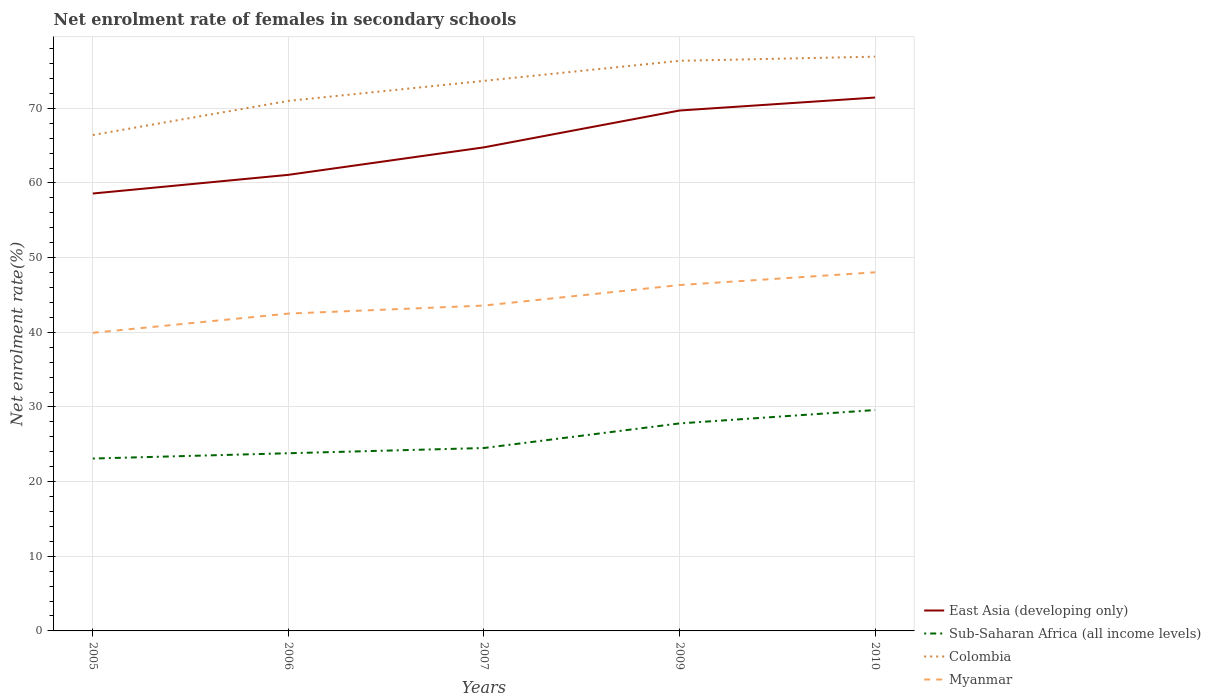How many different coloured lines are there?
Your answer should be very brief. 4. Does the line corresponding to East Asia (developing only) intersect with the line corresponding to Sub-Saharan Africa (all income levels)?
Your response must be concise. No. Is the number of lines equal to the number of legend labels?
Provide a succinct answer. Yes. Across all years, what is the maximum net enrolment rate of females in secondary schools in East Asia (developing only)?
Your answer should be compact. 58.59. What is the total net enrolment rate of females in secondary schools in Sub-Saharan Africa (all income levels) in the graph?
Your answer should be very brief. -0.7. What is the difference between the highest and the second highest net enrolment rate of females in secondary schools in Sub-Saharan Africa (all income levels)?
Offer a very short reply. 6.5. How many years are there in the graph?
Provide a short and direct response. 5. What is the difference between two consecutive major ticks on the Y-axis?
Make the answer very short. 10. Are the values on the major ticks of Y-axis written in scientific E-notation?
Provide a short and direct response. No. Does the graph contain any zero values?
Keep it short and to the point. No. Where does the legend appear in the graph?
Offer a very short reply. Bottom right. How many legend labels are there?
Your response must be concise. 4. What is the title of the graph?
Ensure brevity in your answer.  Net enrolment rate of females in secondary schools. Does "Sub-Saharan Africa (developing only)" appear as one of the legend labels in the graph?
Keep it short and to the point. No. What is the label or title of the Y-axis?
Keep it short and to the point. Net enrolment rate(%). What is the Net enrolment rate(%) in East Asia (developing only) in 2005?
Offer a very short reply. 58.59. What is the Net enrolment rate(%) in Sub-Saharan Africa (all income levels) in 2005?
Your answer should be compact. 23.09. What is the Net enrolment rate(%) of Colombia in 2005?
Provide a succinct answer. 66.43. What is the Net enrolment rate(%) in Myanmar in 2005?
Provide a succinct answer. 39.93. What is the Net enrolment rate(%) in East Asia (developing only) in 2006?
Provide a short and direct response. 61.09. What is the Net enrolment rate(%) of Sub-Saharan Africa (all income levels) in 2006?
Ensure brevity in your answer.  23.8. What is the Net enrolment rate(%) of Colombia in 2006?
Provide a succinct answer. 71. What is the Net enrolment rate(%) in Myanmar in 2006?
Keep it short and to the point. 42.51. What is the Net enrolment rate(%) in East Asia (developing only) in 2007?
Provide a succinct answer. 64.77. What is the Net enrolment rate(%) in Sub-Saharan Africa (all income levels) in 2007?
Provide a succinct answer. 24.5. What is the Net enrolment rate(%) in Colombia in 2007?
Offer a terse response. 73.68. What is the Net enrolment rate(%) in Myanmar in 2007?
Your answer should be compact. 43.58. What is the Net enrolment rate(%) of East Asia (developing only) in 2009?
Your response must be concise. 69.71. What is the Net enrolment rate(%) in Sub-Saharan Africa (all income levels) in 2009?
Your response must be concise. 27.79. What is the Net enrolment rate(%) of Colombia in 2009?
Keep it short and to the point. 76.37. What is the Net enrolment rate(%) of Myanmar in 2009?
Provide a short and direct response. 46.33. What is the Net enrolment rate(%) in East Asia (developing only) in 2010?
Provide a short and direct response. 71.45. What is the Net enrolment rate(%) of Sub-Saharan Africa (all income levels) in 2010?
Keep it short and to the point. 29.59. What is the Net enrolment rate(%) in Colombia in 2010?
Make the answer very short. 76.92. What is the Net enrolment rate(%) of Myanmar in 2010?
Provide a short and direct response. 48.03. Across all years, what is the maximum Net enrolment rate(%) in East Asia (developing only)?
Your answer should be compact. 71.45. Across all years, what is the maximum Net enrolment rate(%) of Sub-Saharan Africa (all income levels)?
Provide a short and direct response. 29.59. Across all years, what is the maximum Net enrolment rate(%) of Colombia?
Make the answer very short. 76.92. Across all years, what is the maximum Net enrolment rate(%) in Myanmar?
Keep it short and to the point. 48.03. Across all years, what is the minimum Net enrolment rate(%) of East Asia (developing only)?
Give a very brief answer. 58.59. Across all years, what is the minimum Net enrolment rate(%) in Sub-Saharan Africa (all income levels)?
Offer a very short reply. 23.09. Across all years, what is the minimum Net enrolment rate(%) of Colombia?
Make the answer very short. 66.43. Across all years, what is the minimum Net enrolment rate(%) in Myanmar?
Give a very brief answer. 39.93. What is the total Net enrolment rate(%) of East Asia (developing only) in the graph?
Your response must be concise. 325.61. What is the total Net enrolment rate(%) in Sub-Saharan Africa (all income levels) in the graph?
Offer a very short reply. 128.78. What is the total Net enrolment rate(%) of Colombia in the graph?
Offer a very short reply. 364.4. What is the total Net enrolment rate(%) in Myanmar in the graph?
Offer a terse response. 220.39. What is the difference between the Net enrolment rate(%) of East Asia (developing only) in 2005 and that in 2006?
Ensure brevity in your answer.  -2.5. What is the difference between the Net enrolment rate(%) in Sub-Saharan Africa (all income levels) in 2005 and that in 2006?
Your response must be concise. -0.71. What is the difference between the Net enrolment rate(%) of Colombia in 2005 and that in 2006?
Make the answer very short. -4.57. What is the difference between the Net enrolment rate(%) in Myanmar in 2005 and that in 2006?
Provide a short and direct response. -2.57. What is the difference between the Net enrolment rate(%) of East Asia (developing only) in 2005 and that in 2007?
Your answer should be very brief. -6.18. What is the difference between the Net enrolment rate(%) in Sub-Saharan Africa (all income levels) in 2005 and that in 2007?
Your answer should be very brief. -1.41. What is the difference between the Net enrolment rate(%) in Colombia in 2005 and that in 2007?
Offer a very short reply. -7.25. What is the difference between the Net enrolment rate(%) of Myanmar in 2005 and that in 2007?
Your answer should be very brief. -3.65. What is the difference between the Net enrolment rate(%) in East Asia (developing only) in 2005 and that in 2009?
Offer a very short reply. -11.12. What is the difference between the Net enrolment rate(%) in Sub-Saharan Africa (all income levels) in 2005 and that in 2009?
Make the answer very short. -4.7. What is the difference between the Net enrolment rate(%) in Colombia in 2005 and that in 2009?
Ensure brevity in your answer.  -9.94. What is the difference between the Net enrolment rate(%) of Myanmar in 2005 and that in 2009?
Your answer should be very brief. -6.39. What is the difference between the Net enrolment rate(%) of East Asia (developing only) in 2005 and that in 2010?
Keep it short and to the point. -12.85. What is the difference between the Net enrolment rate(%) of Sub-Saharan Africa (all income levels) in 2005 and that in 2010?
Provide a succinct answer. -6.5. What is the difference between the Net enrolment rate(%) in Colombia in 2005 and that in 2010?
Ensure brevity in your answer.  -10.49. What is the difference between the Net enrolment rate(%) in Myanmar in 2005 and that in 2010?
Ensure brevity in your answer.  -8.1. What is the difference between the Net enrolment rate(%) in East Asia (developing only) in 2006 and that in 2007?
Provide a short and direct response. -3.68. What is the difference between the Net enrolment rate(%) of Sub-Saharan Africa (all income levels) in 2006 and that in 2007?
Make the answer very short. -0.7. What is the difference between the Net enrolment rate(%) in Colombia in 2006 and that in 2007?
Ensure brevity in your answer.  -2.68. What is the difference between the Net enrolment rate(%) in Myanmar in 2006 and that in 2007?
Keep it short and to the point. -1.08. What is the difference between the Net enrolment rate(%) of East Asia (developing only) in 2006 and that in 2009?
Provide a short and direct response. -8.62. What is the difference between the Net enrolment rate(%) in Sub-Saharan Africa (all income levels) in 2006 and that in 2009?
Your answer should be compact. -3.99. What is the difference between the Net enrolment rate(%) in Colombia in 2006 and that in 2009?
Your answer should be very brief. -5.37. What is the difference between the Net enrolment rate(%) in Myanmar in 2006 and that in 2009?
Your answer should be very brief. -3.82. What is the difference between the Net enrolment rate(%) in East Asia (developing only) in 2006 and that in 2010?
Keep it short and to the point. -10.35. What is the difference between the Net enrolment rate(%) in Sub-Saharan Africa (all income levels) in 2006 and that in 2010?
Make the answer very short. -5.79. What is the difference between the Net enrolment rate(%) in Colombia in 2006 and that in 2010?
Give a very brief answer. -5.92. What is the difference between the Net enrolment rate(%) of Myanmar in 2006 and that in 2010?
Provide a succinct answer. -5.53. What is the difference between the Net enrolment rate(%) in East Asia (developing only) in 2007 and that in 2009?
Make the answer very short. -4.93. What is the difference between the Net enrolment rate(%) of Sub-Saharan Africa (all income levels) in 2007 and that in 2009?
Make the answer very short. -3.29. What is the difference between the Net enrolment rate(%) in Colombia in 2007 and that in 2009?
Provide a succinct answer. -2.68. What is the difference between the Net enrolment rate(%) in Myanmar in 2007 and that in 2009?
Keep it short and to the point. -2.75. What is the difference between the Net enrolment rate(%) in East Asia (developing only) in 2007 and that in 2010?
Give a very brief answer. -6.67. What is the difference between the Net enrolment rate(%) in Sub-Saharan Africa (all income levels) in 2007 and that in 2010?
Give a very brief answer. -5.09. What is the difference between the Net enrolment rate(%) of Colombia in 2007 and that in 2010?
Provide a short and direct response. -3.24. What is the difference between the Net enrolment rate(%) in Myanmar in 2007 and that in 2010?
Your answer should be compact. -4.45. What is the difference between the Net enrolment rate(%) in East Asia (developing only) in 2009 and that in 2010?
Your answer should be compact. -1.74. What is the difference between the Net enrolment rate(%) in Sub-Saharan Africa (all income levels) in 2009 and that in 2010?
Your response must be concise. -1.79. What is the difference between the Net enrolment rate(%) in Colombia in 2009 and that in 2010?
Ensure brevity in your answer.  -0.55. What is the difference between the Net enrolment rate(%) in Myanmar in 2009 and that in 2010?
Your answer should be compact. -1.7. What is the difference between the Net enrolment rate(%) in East Asia (developing only) in 2005 and the Net enrolment rate(%) in Sub-Saharan Africa (all income levels) in 2006?
Make the answer very short. 34.79. What is the difference between the Net enrolment rate(%) in East Asia (developing only) in 2005 and the Net enrolment rate(%) in Colombia in 2006?
Provide a succinct answer. -12.41. What is the difference between the Net enrolment rate(%) of East Asia (developing only) in 2005 and the Net enrolment rate(%) of Myanmar in 2006?
Your response must be concise. 16.09. What is the difference between the Net enrolment rate(%) in Sub-Saharan Africa (all income levels) in 2005 and the Net enrolment rate(%) in Colombia in 2006?
Your answer should be very brief. -47.91. What is the difference between the Net enrolment rate(%) in Sub-Saharan Africa (all income levels) in 2005 and the Net enrolment rate(%) in Myanmar in 2006?
Give a very brief answer. -19.41. What is the difference between the Net enrolment rate(%) in Colombia in 2005 and the Net enrolment rate(%) in Myanmar in 2006?
Your answer should be compact. 23.93. What is the difference between the Net enrolment rate(%) in East Asia (developing only) in 2005 and the Net enrolment rate(%) in Sub-Saharan Africa (all income levels) in 2007?
Offer a very short reply. 34.09. What is the difference between the Net enrolment rate(%) of East Asia (developing only) in 2005 and the Net enrolment rate(%) of Colombia in 2007?
Offer a terse response. -15.09. What is the difference between the Net enrolment rate(%) of East Asia (developing only) in 2005 and the Net enrolment rate(%) of Myanmar in 2007?
Offer a very short reply. 15.01. What is the difference between the Net enrolment rate(%) of Sub-Saharan Africa (all income levels) in 2005 and the Net enrolment rate(%) of Colombia in 2007?
Provide a short and direct response. -50.59. What is the difference between the Net enrolment rate(%) of Sub-Saharan Africa (all income levels) in 2005 and the Net enrolment rate(%) of Myanmar in 2007?
Your answer should be compact. -20.49. What is the difference between the Net enrolment rate(%) in Colombia in 2005 and the Net enrolment rate(%) in Myanmar in 2007?
Give a very brief answer. 22.85. What is the difference between the Net enrolment rate(%) of East Asia (developing only) in 2005 and the Net enrolment rate(%) of Sub-Saharan Africa (all income levels) in 2009?
Offer a terse response. 30.8. What is the difference between the Net enrolment rate(%) of East Asia (developing only) in 2005 and the Net enrolment rate(%) of Colombia in 2009?
Offer a very short reply. -17.78. What is the difference between the Net enrolment rate(%) of East Asia (developing only) in 2005 and the Net enrolment rate(%) of Myanmar in 2009?
Your answer should be very brief. 12.26. What is the difference between the Net enrolment rate(%) in Sub-Saharan Africa (all income levels) in 2005 and the Net enrolment rate(%) in Colombia in 2009?
Give a very brief answer. -53.28. What is the difference between the Net enrolment rate(%) of Sub-Saharan Africa (all income levels) in 2005 and the Net enrolment rate(%) of Myanmar in 2009?
Offer a very short reply. -23.24. What is the difference between the Net enrolment rate(%) in Colombia in 2005 and the Net enrolment rate(%) in Myanmar in 2009?
Provide a succinct answer. 20.1. What is the difference between the Net enrolment rate(%) in East Asia (developing only) in 2005 and the Net enrolment rate(%) in Sub-Saharan Africa (all income levels) in 2010?
Offer a terse response. 29.01. What is the difference between the Net enrolment rate(%) of East Asia (developing only) in 2005 and the Net enrolment rate(%) of Colombia in 2010?
Your answer should be very brief. -18.33. What is the difference between the Net enrolment rate(%) of East Asia (developing only) in 2005 and the Net enrolment rate(%) of Myanmar in 2010?
Keep it short and to the point. 10.56. What is the difference between the Net enrolment rate(%) in Sub-Saharan Africa (all income levels) in 2005 and the Net enrolment rate(%) in Colombia in 2010?
Provide a short and direct response. -53.83. What is the difference between the Net enrolment rate(%) in Sub-Saharan Africa (all income levels) in 2005 and the Net enrolment rate(%) in Myanmar in 2010?
Provide a short and direct response. -24.94. What is the difference between the Net enrolment rate(%) in Colombia in 2005 and the Net enrolment rate(%) in Myanmar in 2010?
Your answer should be compact. 18.4. What is the difference between the Net enrolment rate(%) in East Asia (developing only) in 2006 and the Net enrolment rate(%) in Sub-Saharan Africa (all income levels) in 2007?
Give a very brief answer. 36.59. What is the difference between the Net enrolment rate(%) of East Asia (developing only) in 2006 and the Net enrolment rate(%) of Colombia in 2007?
Make the answer very short. -12.59. What is the difference between the Net enrolment rate(%) in East Asia (developing only) in 2006 and the Net enrolment rate(%) in Myanmar in 2007?
Give a very brief answer. 17.51. What is the difference between the Net enrolment rate(%) of Sub-Saharan Africa (all income levels) in 2006 and the Net enrolment rate(%) of Colombia in 2007?
Keep it short and to the point. -49.88. What is the difference between the Net enrolment rate(%) of Sub-Saharan Africa (all income levels) in 2006 and the Net enrolment rate(%) of Myanmar in 2007?
Give a very brief answer. -19.78. What is the difference between the Net enrolment rate(%) in Colombia in 2006 and the Net enrolment rate(%) in Myanmar in 2007?
Provide a short and direct response. 27.42. What is the difference between the Net enrolment rate(%) of East Asia (developing only) in 2006 and the Net enrolment rate(%) of Sub-Saharan Africa (all income levels) in 2009?
Ensure brevity in your answer.  33.3. What is the difference between the Net enrolment rate(%) in East Asia (developing only) in 2006 and the Net enrolment rate(%) in Colombia in 2009?
Offer a terse response. -15.28. What is the difference between the Net enrolment rate(%) in East Asia (developing only) in 2006 and the Net enrolment rate(%) in Myanmar in 2009?
Offer a very short reply. 14.76. What is the difference between the Net enrolment rate(%) of Sub-Saharan Africa (all income levels) in 2006 and the Net enrolment rate(%) of Colombia in 2009?
Provide a succinct answer. -52.57. What is the difference between the Net enrolment rate(%) in Sub-Saharan Africa (all income levels) in 2006 and the Net enrolment rate(%) in Myanmar in 2009?
Ensure brevity in your answer.  -22.53. What is the difference between the Net enrolment rate(%) of Colombia in 2006 and the Net enrolment rate(%) of Myanmar in 2009?
Give a very brief answer. 24.67. What is the difference between the Net enrolment rate(%) of East Asia (developing only) in 2006 and the Net enrolment rate(%) of Sub-Saharan Africa (all income levels) in 2010?
Ensure brevity in your answer.  31.51. What is the difference between the Net enrolment rate(%) in East Asia (developing only) in 2006 and the Net enrolment rate(%) in Colombia in 2010?
Ensure brevity in your answer.  -15.83. What is the difference between the Net enrolment rate(%) of East Asia (developing only) in 2006 and the Net enrolment rate(%) of Myanmar in 2010?
Your response must be concise. 13.06. What is the difference between the Net enrolment rate(%) of Sub-Saharan Africa (all income levels) in 2006 and the Net enrolment rate(%) of Colombia in 2010?
Make the answer very short. -53.12. What is the difference between the Net enrolment rate(%) of Sub-Saharan Africa (all income levels) in 2006 and the Net enrolment rate(%) of Myanmar in 2010?
Offer a very short reply. -24.23. What is the difference between the Net enrolment rate(%) of Colombia in 2006 and the Net enrolment rate(%) of Myanmar in 2010?
Ensure brevity in your answer.  22.96. What is the difference between the Net enrolment rate(%) in East Asia (developing only) in 2007 and the Net enrolment rate(%) in Sub-Saharan Africa (all income levels) in 2009?
Provide a short and direct response. 36.98. What is the difference between the Net enrolment rate(%) in East Asia (developing only) in 2007 and the Net enrolment rate(%) in Colombia in 2009?
Make the answer very short. -11.59. What is the difference between the Net enrolment rate(%) in East Asia (developing only) in 2007 and the Net enrolment rate(%) in Myanmar in 2009?
Your response must be concise. 18.45. What is the difference between the Net enrolment rate(%) in Sub-Saharan Africa (all income levels) in 2007 and the Net enrolment rate(%) in Colombia in 2009?
Give a very brief answer. -51.87. What is the difference between the Net enrolment rate(%) in Sub-Saharan Africa (all income levels) in 2007 and the Net enrolment rate(%) in Myanmar in 2009?
Offer a very short reply. -21.83. What is the difference between the Net enrolment rate(%) in Colombia in 2007 and the Net enrolment rate(%) in Myanmar in 2009?
Ensure brevity in your answer.  27.35. What is the difference between the Net enrolment rate(%) of East Asia (developing only) in 2007 and the Net enrolment rate(%) of Sub-Saharan Africa (all income levels) in 2010?
Offer a very short reply. 35.19. What is the difference between the Net enrolment rate(%) of East Asia (developing only) in 2007 and the Net enrolment rate(%) of Colombia in 2010?
Your answer should be very brief. -12.15. What is the difference between the Net enrolment rate(%) in East Asia (developing only) in 2007 and the Net enrolment rate(%) in Myanmar in 2010?
Ensure brevity in your answer.  16.74. What is the difference between the Net enrolment rate(%) of Sub-Saharan Africa (all income levels) in 2007 and the Net enrolment rate(%) of Colombia in 2010?
Your answer should be compact. -52.42. What is the difference between the Net enrolment rate(%) of Sub-Saharan Africa (all income levels) in 2007 and the Net enrolment rate(%) of Myanmar in 2010?
Keep it short and to the point. -23.53. What is the difference between the Net enrolment rate(%) in Colombia in 2007 and the Net enrolment rate(%) in Myanmar in 2010?
Keep it short and to the point. 25.65. What is the difference between the Net enrolment rate(%) of East Asia (developing only) in 2009 and the Net enrolment rate(%) of Sub-Saharan Africa (all income levels) in 2010?
Keep it short and to the point. 40.12. What is the difference between the Net enrolment rate(%) in East Asia (developing only) in 2009 and the Net enrolment rate(%) in Colombia in 2010?
Your answer should be very brief. -7.21. What is the difference between the Net enrolment rate(%) of East Asia (developing only) in 2009 and the Net enrolment rate(%) of Myanmar in 2010?
Give a very brief answer. 21.67. What is the difference between the Net enrolment rate(%) of Sub-Saharan Africa (all income levels) in 2009 and the Net enrolment rate(%) of Colombia in 2010?
Your answer should be very brief. -49.13. What is the difference between the Net enrolment rate(%) of Sub-Saharan Africa (all income levels) in 2009 and the Net enrolment rate(%) of Myanmar in 2010?
Give a very brief answer. -20.24. What is the difference between the Net enrolment rate(%) in Colombia in 2009 and the Net enrolment rate(%) in Myanmar in 2010?
Your response must be concise. 28.33. What is the average Net enrolment rate(%) in East Asia (developing only) per year?
Offer a terse response. 65.12. What is the average Net enrolment rate(%) in Sub-Saharan Africa (all income levels) per year?
Provide a short and direct response. 25.75. What is the average Net enrolment rate(%) of Colombia per year?
Provide a succinct answer. 72.88. What is the average Net enrolment rate(%) in Myanmar per year?
Make the answer very short. 44.08. In the year 2005, what is the difference between the Net enrolment rate(%) in East Asia (developing only) and Net enrolment rate(%) in Sub-Saharan Africa (all income levels)?
Your answer should be very brief. 35.5. In the year 2005, what is the difference between the Net enrolment rate(%) in East Asia (developing only) and Net enrolment rate(%) in Colombia?
Give a very brief answer. -7.84. In the year 2005, what is the difference between the Net enrolment rate(%) of East Asia (developing only) and Net enrolment rate(%) of Myanmar?
Keep it short and to the point. 18.66. In the year 2005, what is the difference between the Net enrolment rate(%) in Sub-Saharan Africa (all income levels) and Net enrolment rate(%) in Colombia?
Provide a short and direct response. -43.34. In the year 2005, what is the difference between the Net enrolment rate(%) of Sub-Saharan Africa (all income levels) and Net enrolment rate(%) of Myanmar?
Your response must be concise. -16.84. In the year 2005, what is the difference between the Net enrolment rate(%) of Colombia and Net enrolment rate(%) of Myanmar?
Your response must be concise. 26.5. In the year 2006, what is the difference between the Net enrolment rate(%) in East Asia (developing only) and Net enrolment rate(%) in Sub-Saharan Africa (all income levels)?
Your answer should be very brief. 37.29. In the year 2006, what is the difference between the Net enrolment rate(%) of East Asia (developing only) and Net enrolment rate(%) of Colombia?
Make the answer very short. -9.91. In the year 2006, what is the difference between the Net enrolment rate(%) of East Asia (developing only) and Net enrolment rate(%) of Myanmar?
Provide a succinct answer. 18.59. In the year 2006, what is the difference between the Net enrolment rate(%) of Sub-Saharan Africa (all income levels) and Net enrolment rate(%) of Colombia?
Provide a short and direct response. -47.2. In the year 2006, what is the difference between the Net enrolment rate(%) in Sub-Saharan Africa (all income levels) and Net enrolment rate(%) in Myanmar?
Your answer should be compact. -18.7. In the year 2006, what is the difference between the Net enrolment rate(%) in Colombia and Net enrolment rate(%) in Myanmar?
Provide a short and direct response. 28.49. In the year 2007, what is the difference between the Net enrolment rate(%) of East Asia (developing only) and Net enrolment rate(%) of Sub-Saharan Africa (all income levels)?
Offer a terse response. 40.27. In the year 2007, what is the difference between the Net enrolment rate(%) of East Asia (developing only) and Net enrolment rate(%) of Colombia?
Your response must be concise. -8.91. In the year 2007, what is the difference between the Net enrolment rate(%) in East Asia (developing only) and Net enrolment rate(%) in Myanmar?
Provide a succinct answer. 21.19. In the year 2007, what is the difference between the Net enrolment rate(%) of Sub-Saharan Africa (all income levels) and Net enrolment rate(%) of Colombia?
Ensure brevity in your answer.  -49.18. In the year 2007, what is the difference between the Net enrolment rate(%) in Sub-Saharan Africa (all income levels) and Net enrolment rate(%) in Myanmar?
Provide a succinct answer. -19.08. In the year 2007, what is the difference between the Net enrolment rate(%) of Colombia and Net enrolment rate(%) of Myanmar?
Your answer should be compact. 30.1. In the year 2009, what is the difference between the Net enrolment rate(%) in East Asia (developing only) and Net enrolment rate(%) in Sub-Saharan Africa (all income levels)?
Give a very brief answer. 41.91. In the year 2009, what is the difference between the Net enrolment rate(%) in East Asia (developing only) and Net enrolment rate(%) in Colombia?
Make the answer very short. -6.66. In the year 2009, what is the difference between the Net enrolment rate(%) of East Asia (developing only) and Net enrolment rate(%) of Myanmar?
Make the answer very short. 23.38. In the year 2009, what is the difference between the Net enrolment rate(%) in Sub-Saharan Africa (all income levels) and Net enrolment rate(%) in Colombia?
Provide a succinct answer. -48.57. In the year 2009, what is the difference between the Net enrolment rate(%) of Sub-Saharan Africa (all income levels) and Net enrolment rate(%) of Myanmar?
Offer a very short reply. -18.53. In the year 2009, what is the difference between the Net enrolment rate(%) in Colombia and Net enrolment rate(%) in Myanmar?
Your answer should be very brief. 30.04. In the year 2010, what is the difference between the Net enrolment rate(%) of East Asia (developing only) and Net enrolment rate(%) of Sub-Saharan Africa (all income levels)?
Provide a succinct answer. 41.86. In the year 2010, what is the difference between the Net enrolment rate(%) in East Asia (developing only) and Net enrolment rate(%) in Colombia?
Make the answer very short. -5.47. In the year 2010, what is the difference between the Net enrolment rate(%) of East Asia (developing only) and Net enrolment rate(%) of Myanmar?
Keep it short and to the point. 23.41. In the year 2010, what is the difference between the Net enrolment rate(%) of Sub-Saharan Africa (all income levels) and Net enrolment rate(%) of Colombia?
Your answer should be very brief. -47.33. In the year 2010, what is the difference between the Net enrolment rate(%) in Sub-Saharan Africa (all income levels) and Net enrolment rate(%) in Myanmar?
Give a very brief answer. -18.45. In the year 2010, what is the difference between the Net enrolment rate(%) of Colombia and Net enrolment rate(%) of Myanmar?
Your answer should be very brief. 28.89. What is the ratio of the Net enrolment rate(%) in East Asia (developing only) in 2005 to that in 2006?
Keep it short and to the point. 0.96. What is the ratio of the Net enrolment rate(%) of Sub-Saharan Africa (all income levels) in 2005 to that in 2006?
Offer a terse response. 0.97. What is the ratio of the Net enrolment rate(%) of Colombia in 2005 to that in 2006?
Provide a succinct answer. 0.94. What is the ratio of the Net enrolment rate(%) of Myanmar in 2005 to that in 2006?
Ensure brevity in your answer.  0.94. What is the ratio of the Net enrolment rate(%) of East Asia (developing only) in 2005 to that in 2007?
Ensure brevity in your answer.  0.9. What is the ratio of the Net enrolment rate(%) in Sub-Saharan Africa (all income levels) in 2005 to that in 2007?
Provide a short and direct response. 0.94. What is the ratio of the Net enrolment rate(%) of Colombia in 2005 to that in 2007?
Your answer should be compact. 0.9. What is the ratio of the Net enrolment rate(%) in Myanmar in 2005 to that in 2007?
Provide a succinct answer. 0.92. What is the ratio of the Net enrolment rate(%) in East Asia (developing only) in 2005 to that in 2009?
Provide a short and direct response. 0.84. What is the ratio of the Net enrolment rate(%) of Sub-Saharan Africa (all income levels) in 2005 to that in 2009?
Offer a very short reply. 0.83. What is the ratio of the Net enrolment rate(%) of Colombia in 2005 to that in 2009?
Ensure brevity in your answer.  0.87. What is the ratio of the Net enrolment rate(%) of Myanmar in 2005 to that in 2009?
Your answer should be very brief. 0.86. What is the ratio of the Net enrolment rate(%) in East Asia (developing only) in 2005 to that in 2010?
Make the answer very short. 0.82. What is the ratio of the Net enrolment rate(%) of Sub-Saharan Africa (all income levels) in 2005 to that in 2010?
Offer a very short reply. 0.78. What is the ratio of the Net enrolment rate(%) in Colombia in 2005 to that in 2010?
Provide a succinct answer. 0.86. What is the ratio of the Net enrolment rate(%) in Myanmar in 2005 to that in 2010?
Give a very brief answer. 0.83. What is the ratio of the Net enrolment rate(%) in East Asia (developing only) in 2006 to that in 2007?
Provide a short and direct response. 0.94. What is the ratio of the Net enrolment rate(%) in Sub-Saharan Africa (all income levels) in 2006 to that in 2007?
Ensure brevity in your answer.  0.97. What is the ratio of the Net enrolment rate(%) in Colombia in 2006 to that in 2007?
Ensure brevity in your answer.  0.96. What is the ratio of the Net enrolment rate(%) of Myanmar in 2006 to that in 2007?
Offer a terse response. 0.98. What is the ratio of the Net enrolment rate(%) of East Asia (developing only) in 2006 to that in 2009?
Your response must be concise. 0.88. What is the ratio of the Net enrolment rate(%) in Sub-Saharan Africa (all income levels) in 2006 to that in 2009?
Ensure brevity in your answer.  0.86. What is the ratio of the Net enrolment rate(%) of Colombia in 2006 to that in 2009?
Offer a very short reply. 0.93. What is the ratio of the Net enrolment rate(%) in Myanmar in 2006 to that in 2009?
Your answer should be compact. 0.92. What is the ratio of the Net enrolment rate(%) of East Asia (developing only) in 2006 to that in 2010?
Ensure brevity in your answer.  0.86. What is the ratio of the Net enrolment rate(%) in Sub-Saharan Africa (all income levels) in 2006 to that in 2010?
Provide a succinct answer. 0.8. What is the ratio of the Net enrolment rate(%) of Colombia in 2006 to that in 2010?
Provide a short and direct response. 0.92. What is the ratio of the Net enrolment rate(%) in Myanmar in 2006 to that in 2010?
Offer a terse response. 0.88. What is the ratio of the Net enrolment rate(%) of East Asia (developing only) in 2007 to that in 2009?
Ensure brevity in your answer.  0.93. What is the ratio of the Net enrolment rate(%) in Sub-Saharan Africa (all income levels) in 2007 to that in 2009?
Offer a terse response. 0.88. What is the ratio of the Net enrolment rate(%) of Colombia in 2007 to that in 2009?
Your answer should be very brief. 0.96. What is the ratio of the Net enrolment rate(%) of Myanmar in 2007 to that in 2009?
Ensure brevity in your answer.  0.94. What is the ratio of the Net enrolment rate(%) of East Asia (developing only) in 2007 to that in 2010?
Provide a succinct answer. 0.91. What is the ratio of the Net enrolment rate(%) in Sub-Saharan Africa (all income levels) in 2007 to that in 2010?
Offer a very short reply. 0.83. What is the ratio of the Net enrolment rate(%) in Colombia in 2007 to that in 2010?
Give a very brief answer. 0.96. What is the ratio of the Net enrolment rate(%) of Myanmar in 2007 to that in 2010?
Provide a short and direct response. 0.91. What is the ratio of the Net enrolment rate(%) in East Asia (developing only) in 2009 to that in 2010?
Offer a very short reply. 0.98. What is the ratio of the Net enrolment rate(%) of Sub-Saharan Africa (all income levels) in 2009 to that in 2010?
Keep it short and to the point. 0.94. What is the ratio of the Net enrolment rate(%) in Myanmar in 2009 to that in 2010?
Ensure brevity in your answer.  0.96. What is the difference between the highest and the second highest Net enrolment rate(%) in East Asia (developing only)?
Your response must be concise. 1.74. What is the difference between the highest and the second highest Net enrolment rate(%) in Sub-Saharan Africa (all income levels)?
Your answer should be compact. 1.79. What is the difference between the highest and the second highest Net enrolment rate(%) in Colombia?
Offer a terse response. 0.55. What is the difference between the highest and the second highest Net enrolment rate(%) in Myanmar?
Offer a terse response. 1.7. What is the difference between the highest and the lowest Net enrolment rate(%) of East Asia (developing only)?
Ensure brevity in your answer.  12.85. What is the difference between the highest and the lowest Net enrolment rate(%) in Sub-Saharan Africa (all income levels)?
Offer a terse response. 6.5. What is the difference between the highest and the lowest Net enrolment rate(%) in Colombia?
Your answer should be very brief. 10.49. What is the difference between the highest and the lowest Net enrolment rate(%) in Myanmar?
Offer a terse response. 8.1. 